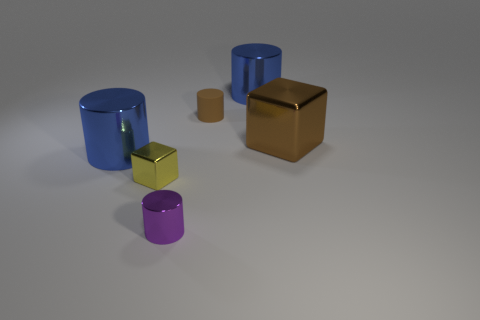Subtract all small rubber cylinders. How many cylinders are left? 3 Subtract all blue metallic objects. Subtract all brown metallic blocks. How many objects are left? 3 Add 3 blue metal things. How many blue metal things are left? 5 Add 1 small shiny blocks. How many small shiny blocks exist? 2 Add 3 tiny purple shiny cylinders. How many objects exist? 9 Subtract all yellow cubes. How many cubes are left? 1 Subtract 0 green balls. How many objects are left? 6 Subtract all cylinders. How many objects are left? 2 Subtract 1 blocks. How many blocks are left? 1 Subtract all purple cylinders. Subtract all green blocks. How many cylinders are left? 3 